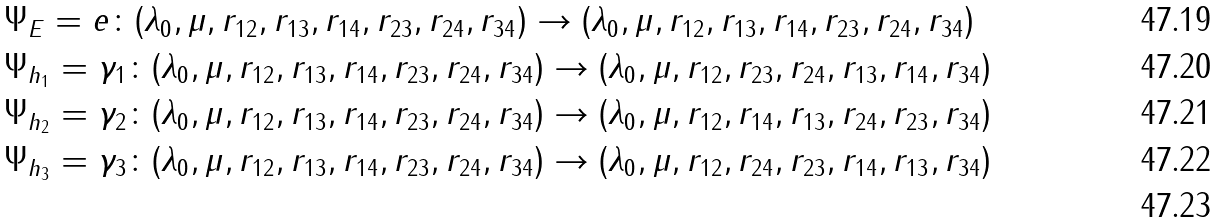Convert formula to latex. <formula><loc_0><loc_0><loc_500><loc_500>& \Psi _ { E } = e \colon ( \lambda _ { 0 } , \mu , r _ { 1 2 } , r _ { 1 3 } , r _ { 1 4 } , r _ { 2 3 } , r _ { 2 4 } , r _ { 3 4 } ) \rightarrow ( \lambda _ { 0 } , \mu , r _ { 1 2 } , r _ { 1 3 } , r _ { 1 4 } , r _ { 2 3 } , r _ { 2 4 } , r _ { 3 4 } ) \\ & \Psi _ { h _ { 1 } } = \gamma _ { 1 } \colon ( \lambda _ { 0 } , \mu , r _ { 1 2 } , r _ { 1 3 } , r _ { 1 4 } , r _ { 2 3 } , r _ { 2 4 } , r _ { 3 4 } ) \rightarrow ( \lambda _ { 0 } , \mu , r _ { 1 2 } , r _ { 2 3 } , r _ { 2 4 } , r _ { 1 3 } , r _ { 1 4 } , r _ { 3 4 } ) \\ & \Psi _ { h _ { 2 } } = \gamma _ { 2 } \colon ( \lambda _ { 0 } , \mu , r _ { 1 2 } , r _ { 1 3 } , r _ { 1 4 } , r _ { 2 3 } , r _ { 2 4 } , r _ { 3 4 } ) \rightarrow ( \lambda _ { 0 } , \mu , r _ { 1 2 } , r _ { 1 4 } , r _ { 1 3 } , r _ { 2 4 } , r _ { 2 3 } , r _ { 3 4 } ) \\ & \Psi _ { h _ { 3 } } = \gamma _ { 3 } \colon ( \lambda _ { 0 } , \mu , r _ { 1 2 } , r _ { 1 3 } , r _ { 1 4 } , r _ { 2 3 } , r _ { 2 4 } , r _ { 3 4 } ) \rightarrow ( \lambda _ { 0 } , \mu , r _ { 1 2 } , r _ { 2 4 } , r _ { 2 3 } , r _ { 1 4 } , r _ { 1 3 } , r _ { 3 4 } ) \\</formula> 